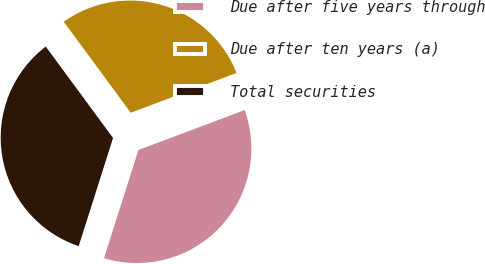Convert chart to OTSL. <chart><loc_0><loc_0><loc_500><loc_500><pie_chart><fcel>Due after five years through<fcel>Due after ten years (a)<fcel>Total securities<nl><fcel>35.62%<fcel>29.38%<fcel>35.0%<nl></chart> 